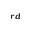<formula> <loc_0><loc_0><loc_500><loc_500>^ { r d }</formula> 